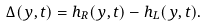<formula> <loc_0><loc_0><loc_500><loc_500>\Delta ( y , t ) = h _ { R } ( y , t ) - h _ { L } ( y , t ) .</formula> 